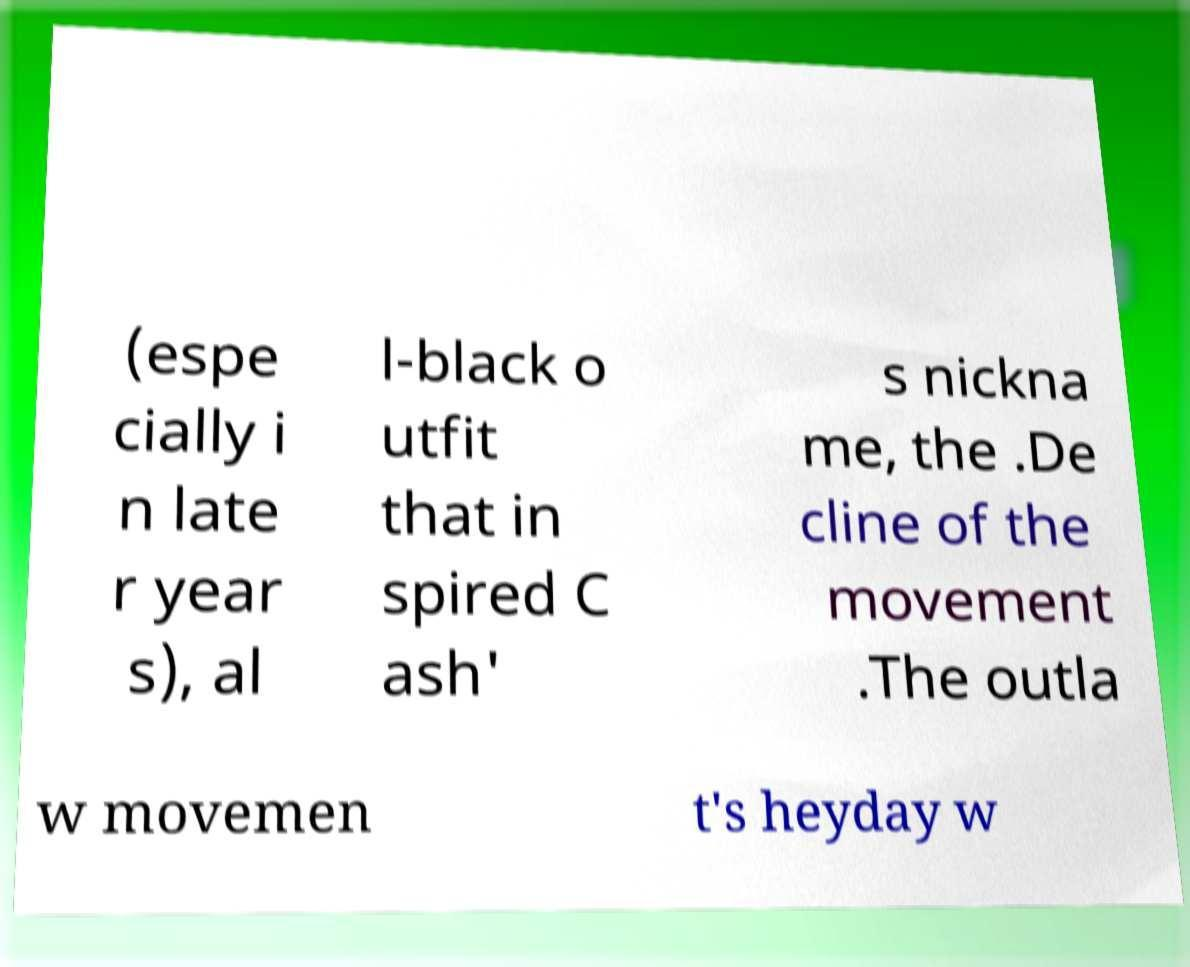Can you accurately transcribe the text from the provided image for me? (espe cially i n late r year s), al l-black o utfit that in spired C ash' s nickna me, the .De cline of the movement .The outla w movemen t's heyday w 